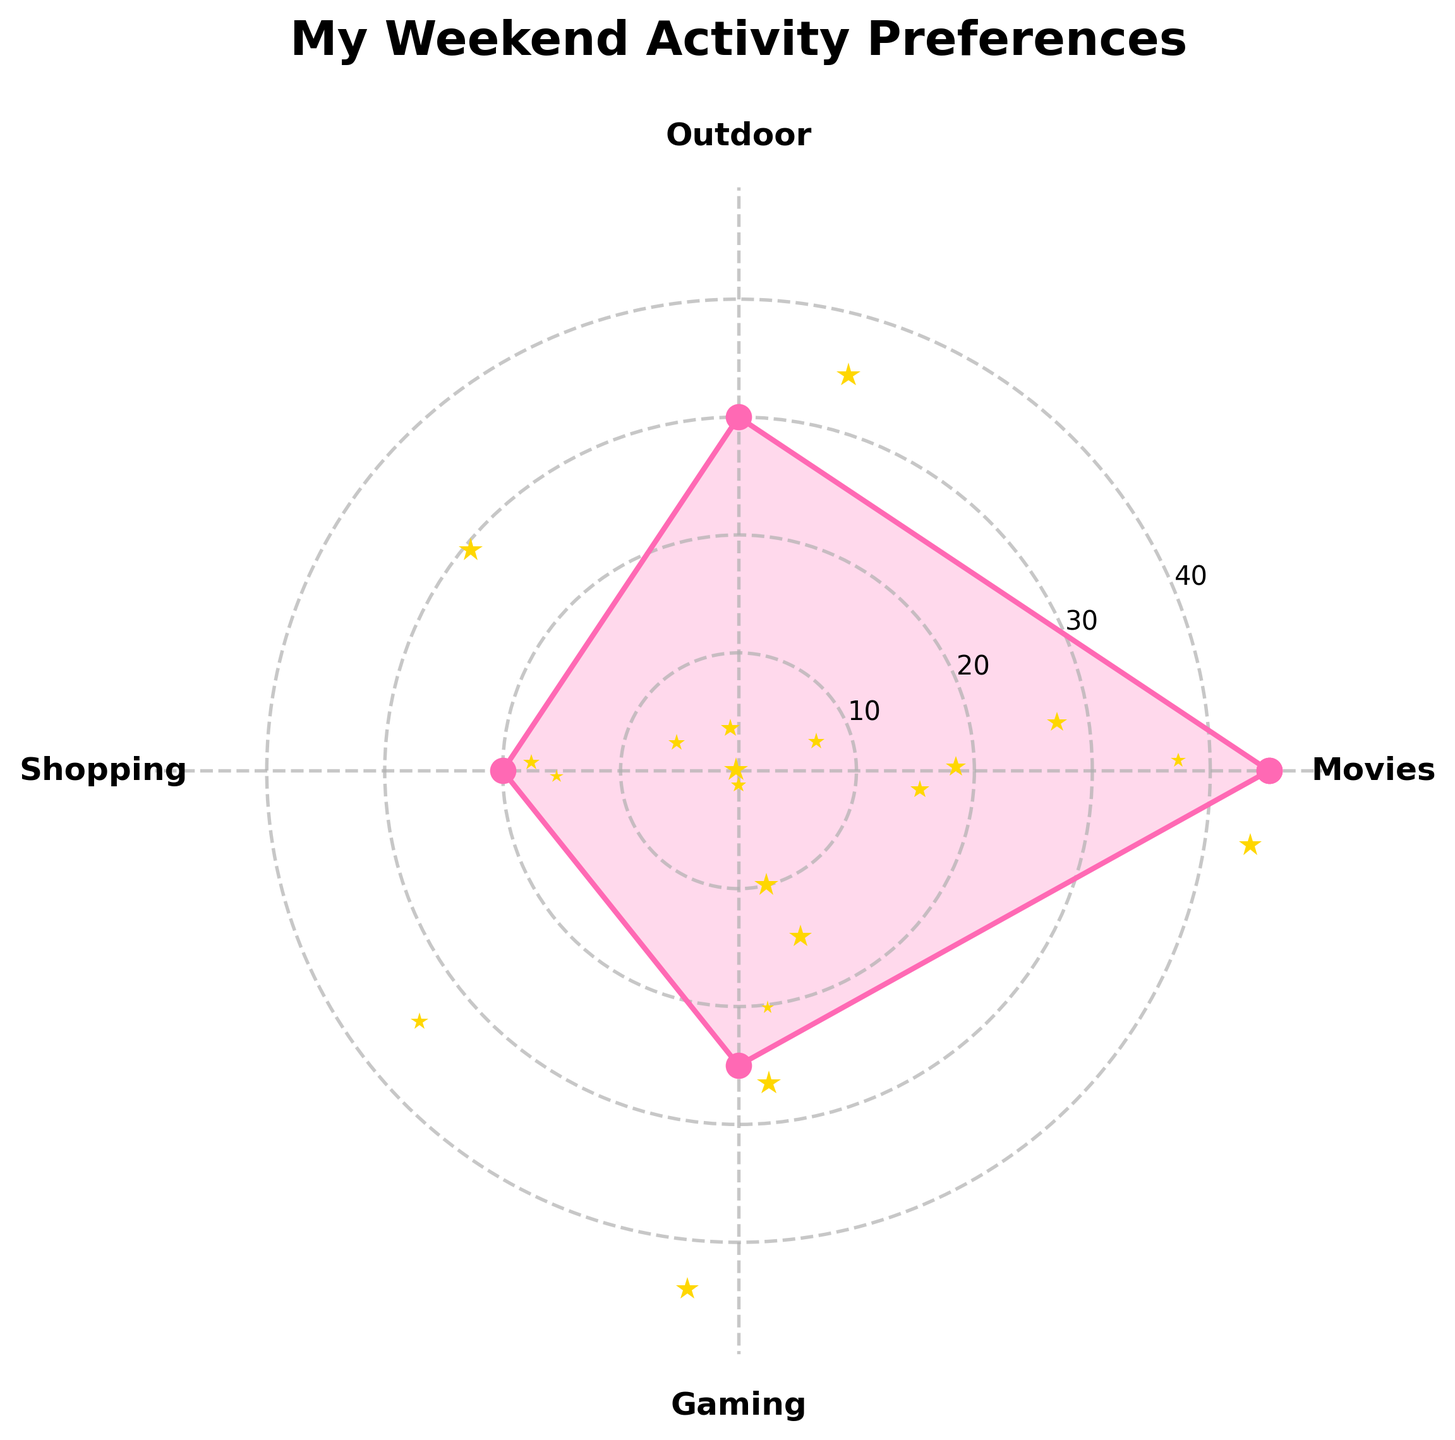What's the title of the rose chart? The title is the large text above the chart, typically describing the content of the chart. Here, it reads "My Weekend Activity Preferences".
Answer: My Weekend Activity Preferences How many different weekend activities are represented in the chart? The number of activities is equal to the number of sections in the rose chart. The chart shows sections labeled "Movies," "Outdoor," "Shopping," and "Gaming," which makes 4 activities.
Answer: 4 Which activity has the highest preference count? From the chart, identify the activity with the longest radial line, which corresponds to the highest value. "Movies" has the longest line, indicating it has the highest count.
Answer: Movies What's the difference in preference count between "Movies" and "Outdoor"? Locate the counts on the rose chart for "Movies" and "Outdoor." "Movies" has a count of 45, and "Outdoor" has a count of 30. Subtract the two values (45 - 30).
Answer: 15 Which two activities have the most similar preference counts? Compare the length of lines for each activity. The lines for "Outdoor" (30) and "Gaming" (25) are the most similar in length and numerical value.
Answer: Outdoor and Gaming What is the average preference count for "Shopping" and "Gaming"? Add the preference counts for "Shopping" (20) and "Gaming" (25). Then, divide by 2 to find the average (20 + 25) / 2.
Answer: 22.5 Rank the activities from most preferred to least preferred. Order the activities based on the length of their radial lines, which represent their counts: Movies (45), Outdoor (30), Gaming (25), Shopping (20).
Answer: Movies, Outdoor, Gaming, Shopping What's the total preference count for all activities combined? Sum the preference counts of all the activities: 45 (Movies) + 30 (Outdoor) + 20 (Shopping) + 25 (Gaming).
Answer: 120 Which activity has the lowest preference count? Identify the shortest radial line in the rose chart. The shortest line corresponds to "Shopping," which has the lowest count.
Answer: Shopping 